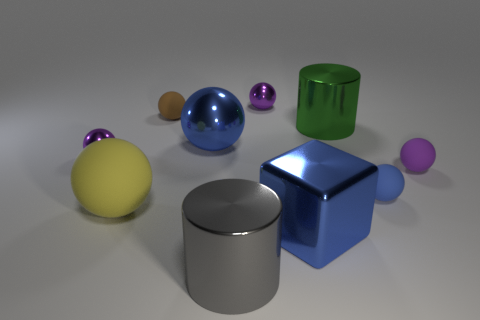Is the shape of the tiny purple object that is on the right side of the green thing the same as the purple metal thing on the right side of the large blue shiny sphere?
Provide a succinct answer. Yes. Are there fewer purple rubber spheres that are behind the brown thing than tiny green metallic objects?
Your response must be concise. No. How many shiny cylinders are the same color as the block?
Provide a short and direct response. 0. How big is the purple thing right of the large green object?
Your answer should be very brief. Small. There is a small metal thing to the left of the tiny purple shiny ball behind the small brown ball behind the big rubber object; what shape is it?
Provide a short and direct response. Sphere. What shape is the big shiny thing that is both to the left of the blue metallic cube and behind the purple matte sphere?
Ensure brevity in your answer.  Sphere. Are there any blue spheres of the same size as the blue matte object?
Offer a terse response. No. Is the shape of the blue metallic object that is behind the yellow thing the same as  the small purple rubber thing?
Your answer should be very brief. Yes. Is the big gray thing the same shape as the big green shiny object?
Give a very brief answer. Yes. Are there any tiny blue things that have the same shape as the large green shiny object?
Provide a succinct answer. No. 